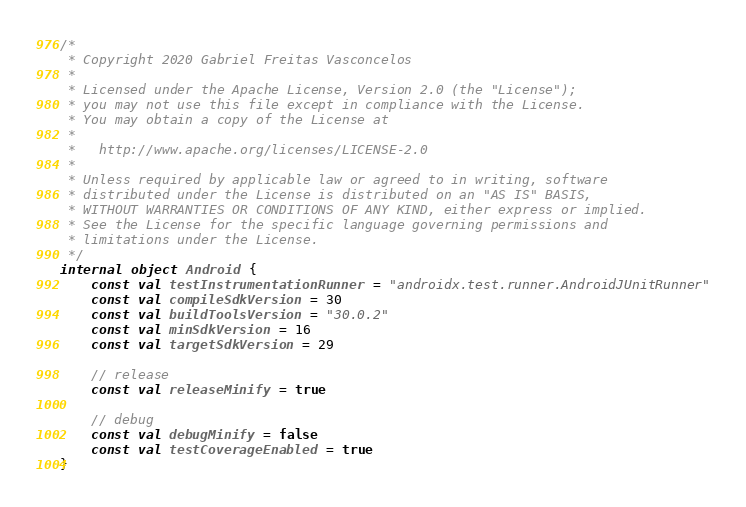Convert code to text. <code><loc_0><loc_0><loc_500><loc_500><_Kotlin_>/*
 * Copyright 2020 Gabriel Freitas Vasconcelos
 *
 * Licensed under the Apache License, Version 2.0 (the "License");
 * you may not use this file except in compliance with the License.
 * You may obtain a copy of the License at
 *
 *   http://www.apache.org/licenses/LICENSE-2.0
 *
 * Unless required by applicable law or agreed to in writing, software
 * distributed under the License is distributed on an "AS IS" BASIS,
 * WITHOUT WARRANTIES OR CONDITIONS OF ANY KIND, either express or implied.
 * See the License for the specific language governing permissions and
 * limitations under the License.
 */
internal object Android {
    const val testInstrumentationRunner = "androidx.test.runner.AndroidJUnitRunner"
    const val compileSdkVersion = 30
    const val buildToolsVersion = "30.0.2"
    const val minSdkVersion = 16
    const val targetSdkVersion = 29

    // release
    const val releaseMinify = true

    // debug
    const val debugMinify = false
    const val testCoverageEnabled = true
}
</code> 